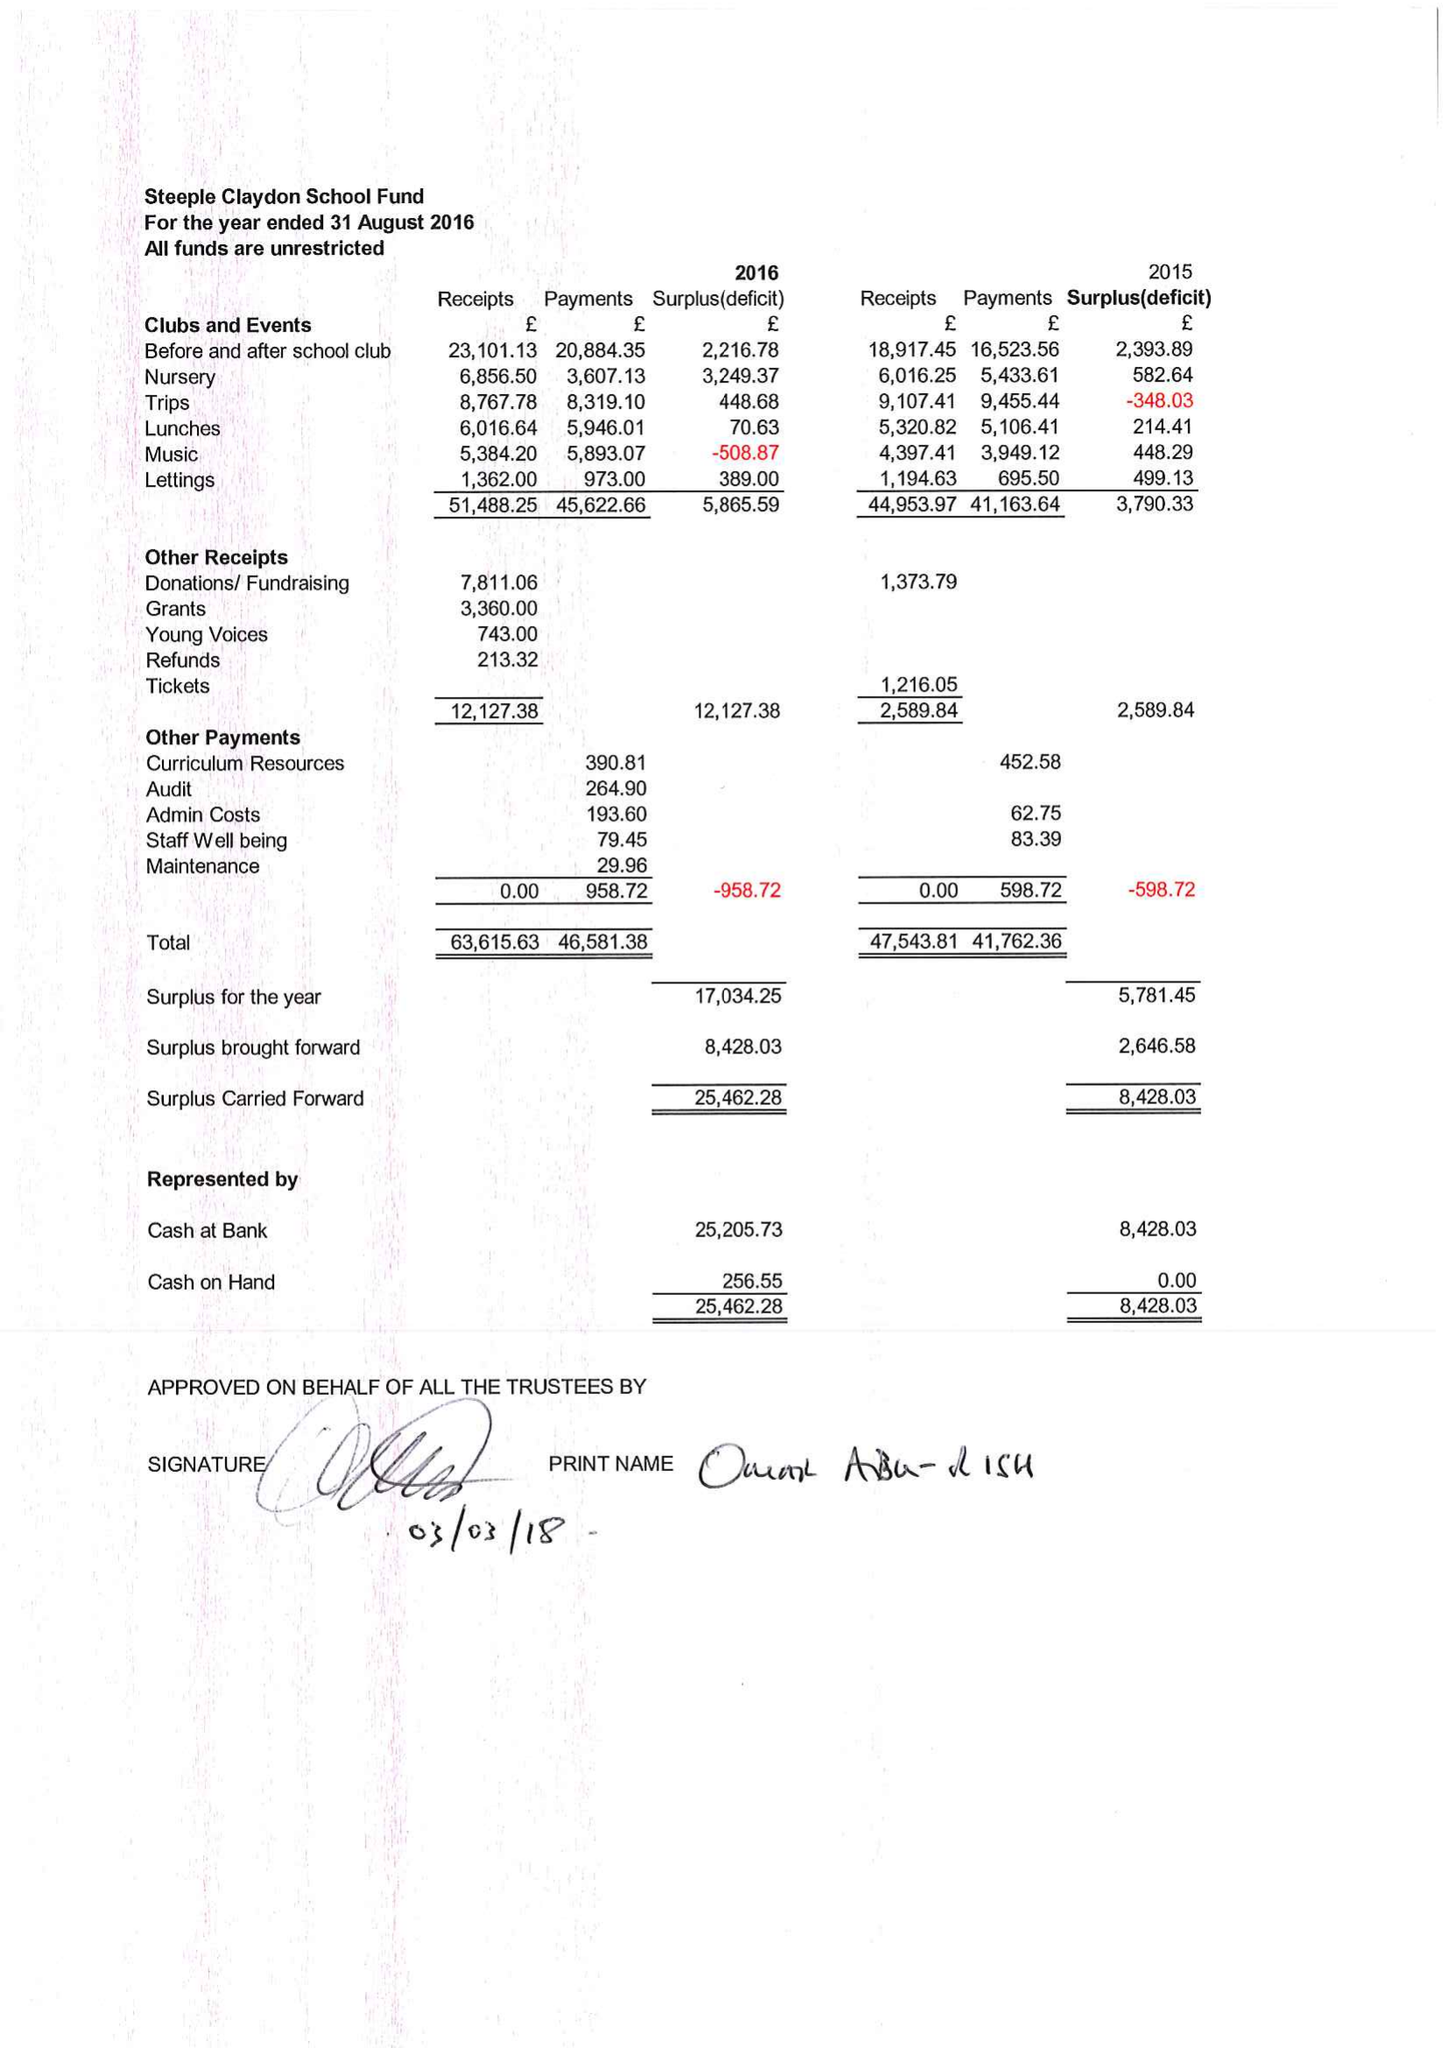What is the value for the address__post_town?
Answer the question using a single word or phrase. BUCKINGHAM 